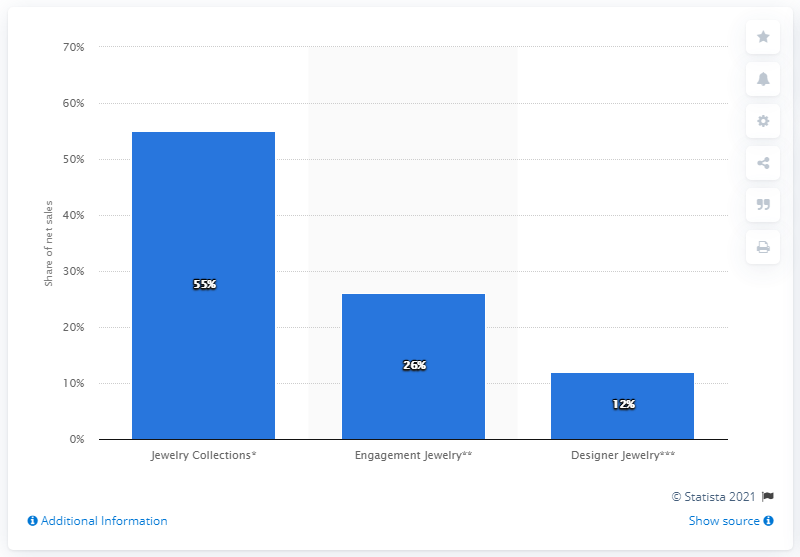Highlight a few significant elements in this photo. In 2019, Tiffany & Co.'s fashion jewelry collections accounted for 55% of the company's net sales. The value of the middle bar is 26. 